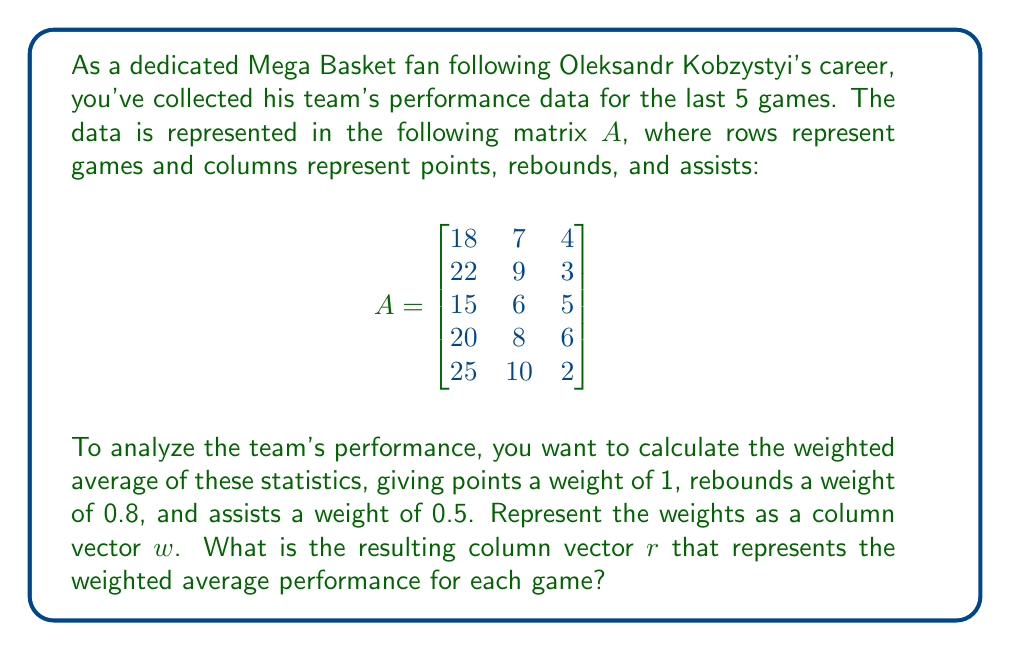Teach me how to tackle this problem. Let's approach this step-by-step:

1) First, we need to set up our weight vector $w$:

   $$w = \begin{bmatrix}
   1 \\
   0.8 \\
   0.5
   \end{bmatrix}$$

2) To calculate the weighted average for each game, we need to multiply matrix $A$ by vector $w$. This is done using matrix multiplication:

   $$r = A \cdot w$$

3) Let's perform this multiplication:

   $$\begin{bmatrix}
   18 & 7 & 4 \\
   22 & 9 & 3 \\
   15 & 6 & 5 \\
   20 & 8 & 6 \\
   25 & 10 & 2
   \end{bmatrix} \cdot 
   \begin{bmatrix}
   1 \\
   0.8 \\
   0.5
   \end{bmatrix}$$

4) Multiplying each row of $A$ by $w$:

   Game 1: $18(1) + 7(0.8) + 4(0.5) = 18 + 5.6 + 2 = 25.6$
   Game 2: $22(1) + 9(0.8) + 3(0.5) = 22 + 7.2 + 1.5 = 30.7$
   Game 3: $15(1) + 6(0.8) + 5(0.5) = 15 + 4.8 + 2.5 = 22.3$
   Game 4: $20(1) + 8(0.8) + 6(0.5) = 20 + 6.4 + 3 = 29.4$
   Game 5: $25(1) + 10(0.8) + 2(0.5) = 25 + 8 + 1 = 34$

5) Therefore, our resulting column vector $r$ is:

   $$r = \begin{bmatrix}
   25.6 \\
   30.7 \\
   22.3 \\
   29.4 \\
   34
   \end{bmatrix}$$

This vector represents the weighted average performance for each of the 5 games.
Answer: $$r = \begin{bmatrix}
25.6 \\
30.7 \\
22.3 \\
29.4 \\
34
\end{bmatrix}$$ 